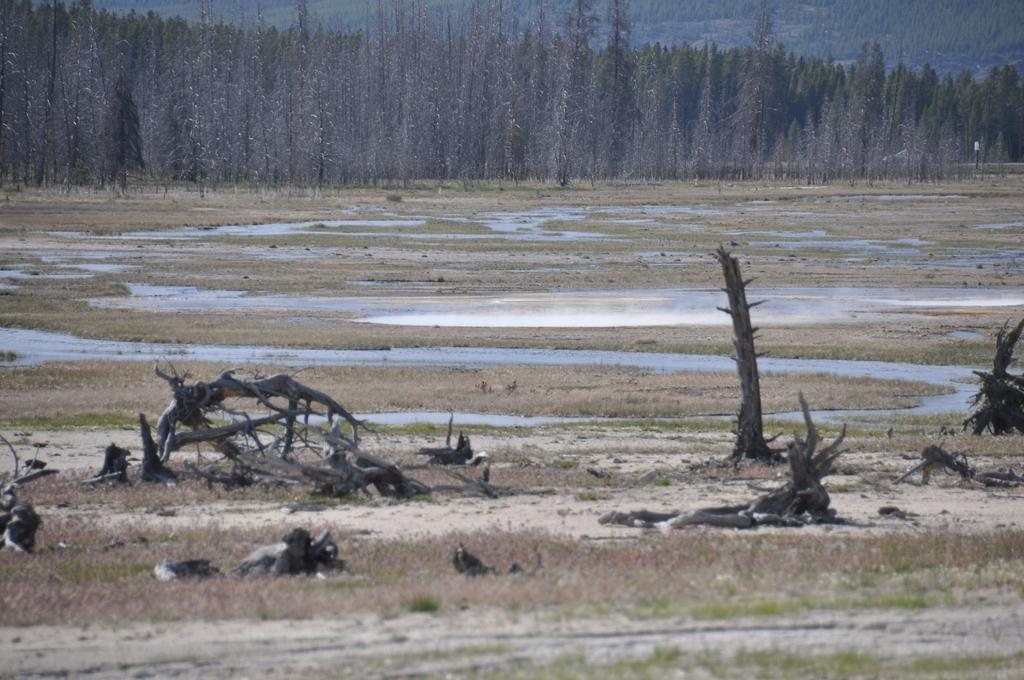What type of surface can be seen in the image? There is ground visible in the image. What is covering the ground? There is grass on the ground. What else can be seen besides the ground and grass? There is water visible in the image. What can be seen in the distance in the image? There are trees in the background of the image. What colors are the trees? The trees are green and brown in color. What type of hair can be seen on the trees in the image? There is no hair present on the trees in the image; they are green and brown in color. What pump is visible in the image? There is no pump present in the image. 